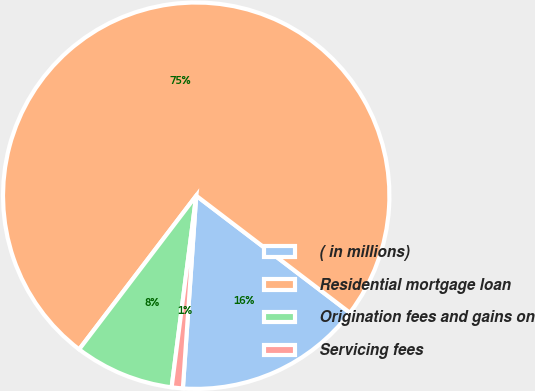<chart> <loc_0><loc_0><loc_500><loc_500><pie_chart><fcel>( in millions)<fcel>Residential mortgage loan<fcel>Origination fees and gains on<fcel>Servicing fees<nl><fcel>15.74%<fcel>75.0%<fcel>8.33%<fcel>0.93%<nl></chart> 